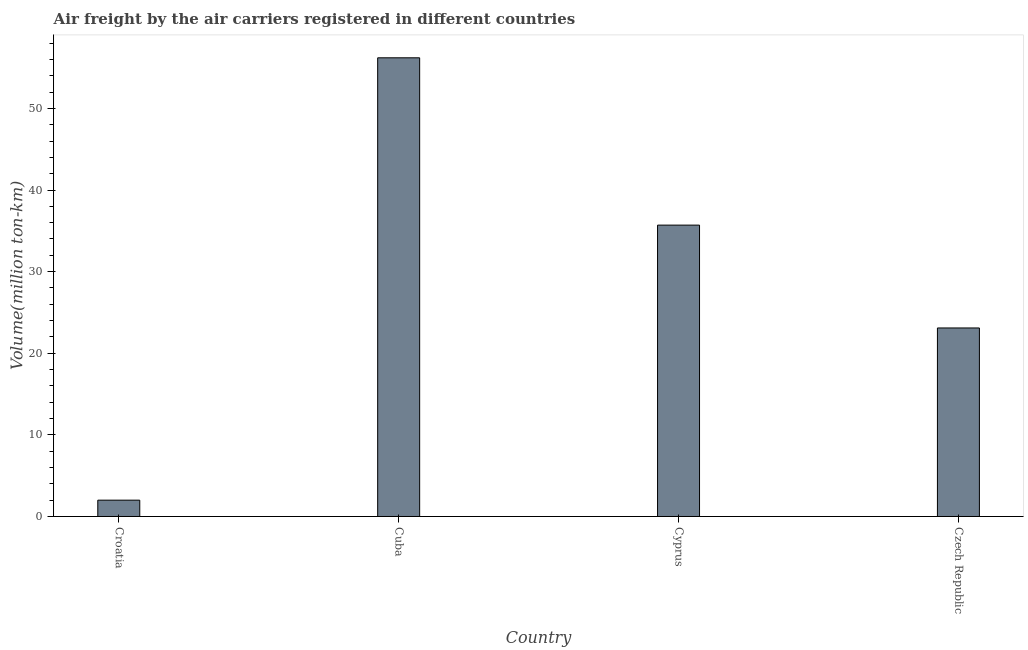What is the title of the graph?
Your answer should be compact. Air freight by the air carriers registered in different countries. What is the label or title of the Y-axis?
Provide a short and direct response. Volume(million ton-km). What is the air freight in Cyprus?
Your answer should be compact. 35.7. Across all countries, what is the maximum air freight?
Your answer should be very brief. 56.2. Across all countries, what is the minimum air freight?
Your response must be concise. 2. In which country was the air freight maximum?
Provide a succinct answer. Cuba. In which country was the air freight minimum?
Offer a very short reply. Croatia. What is the sum of the air freight?
Your response must be concise. 117. What is the difference between the air freight in Croatia and Cyprus?
Give a very brief answer. -33.7. What is the average air freight per country?
Give a very brief answer. 29.25. What is the median air freight?
Your response must be concise. 29.4. What is the ratio of the air freight in Croatia to that in Czech Republic?
Your answer should be very brief. 0.09. Is the air freight in Croatia less than that in Cyprus?
Your answer should be very brief. Yes. Is the difference between the air freight in Cuba and Czech Republic greater than the difference between any two countries?
Provide a short and direct response. No. Is the sum of the air freight in Cyprus and Czech Republic greater than the maximum air freight across all countries?
Your answer should be compact. Yes. What is the difference between the highest and the lowest air freight?
Your answer should be compact. 54.2. In how many countries, is the air freight greater than the average air freight taken over all countries?
Ensure brevity in your answer.  2. Are all the bars in the graph horizontal?
Offer a very short reply. No. What is the difference between two consecutive major ticks on the Y-axis?
Ensure brevity in your answer.  10. Are the values on the major ticks of Y-axis written in scientific E-notation?
Give a very brief answer. No. What is the Volume(million ton-km) in Cuba?
Your answer should be compact. 56.2. What is the Volume(million ton-km) of Cyprus?
Your response must be concise. 35.7. What is the Volume(million ton-km) of Czech Republic?
Give a very brief answer. 23.1. What is the difference between the Volume(million ton-km) in Croatia and Cuba?
Keep it short and to the point. -54.2. What is the difference between the Volume(million ton-km) in Croatia and Cyprus?
Your answer should be very brief. -33.7. What is the difference between the Volume(million ton-km) in Croatia and Czech Republic?
Your answer should be very brief. -21.1. What is the difference between the Volume(million ton-km) in Cuba and Cyprus?
Your answer should be compact. 20.5. What is the difference between the Volume(million ton-km) in Cuba and Czech Republic?
Give a very brief answer. 33.1. What is the ratio of the Volume(million ton-km) in Croatia to that in Cuba?
Ensure brevity in your answer.  0.04. What is the ratio of the Volume(million ton-km) in Croatia to that in Cyprus?
Your answer should be very brief. 0.06. What is the ratio of the Volume(million ton-km) in Croatia to that in Czech Republic?
Provide a short and direct response. 0.09. What is the ratio of the Volume(million ton-km) in Cuba to that in Cyprus?
Ensure brevity in your answer.  1.57. What is the ratio of the Volume(million ton-km) in Cuba to that in Czech Republic?
Offer a very short reply. 2.43. What is the ratio of the Volume(million ton-km) in Cyprus to that in Czech Republic?
Provide a succinct answer. 1.54. 